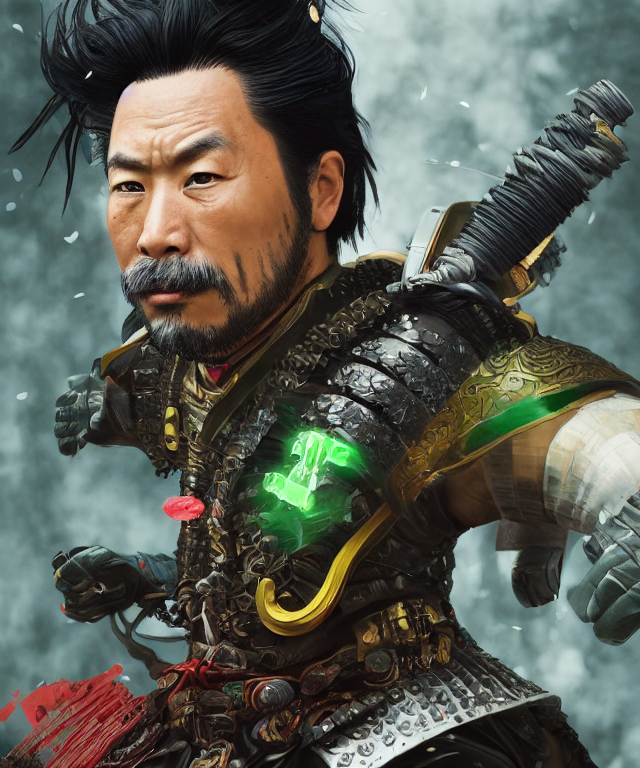Does the image seem to represent a historical figure or is it more fantastical? While the armor points toward historical samurai, the overall rendering gives the image a fantastical edge. Traditional elements are mixed with fantasy, like the otherworldly green glow, making it unlikely to represent a specific historical figure and more indicative of a character from fantasy-inspired fiction. 